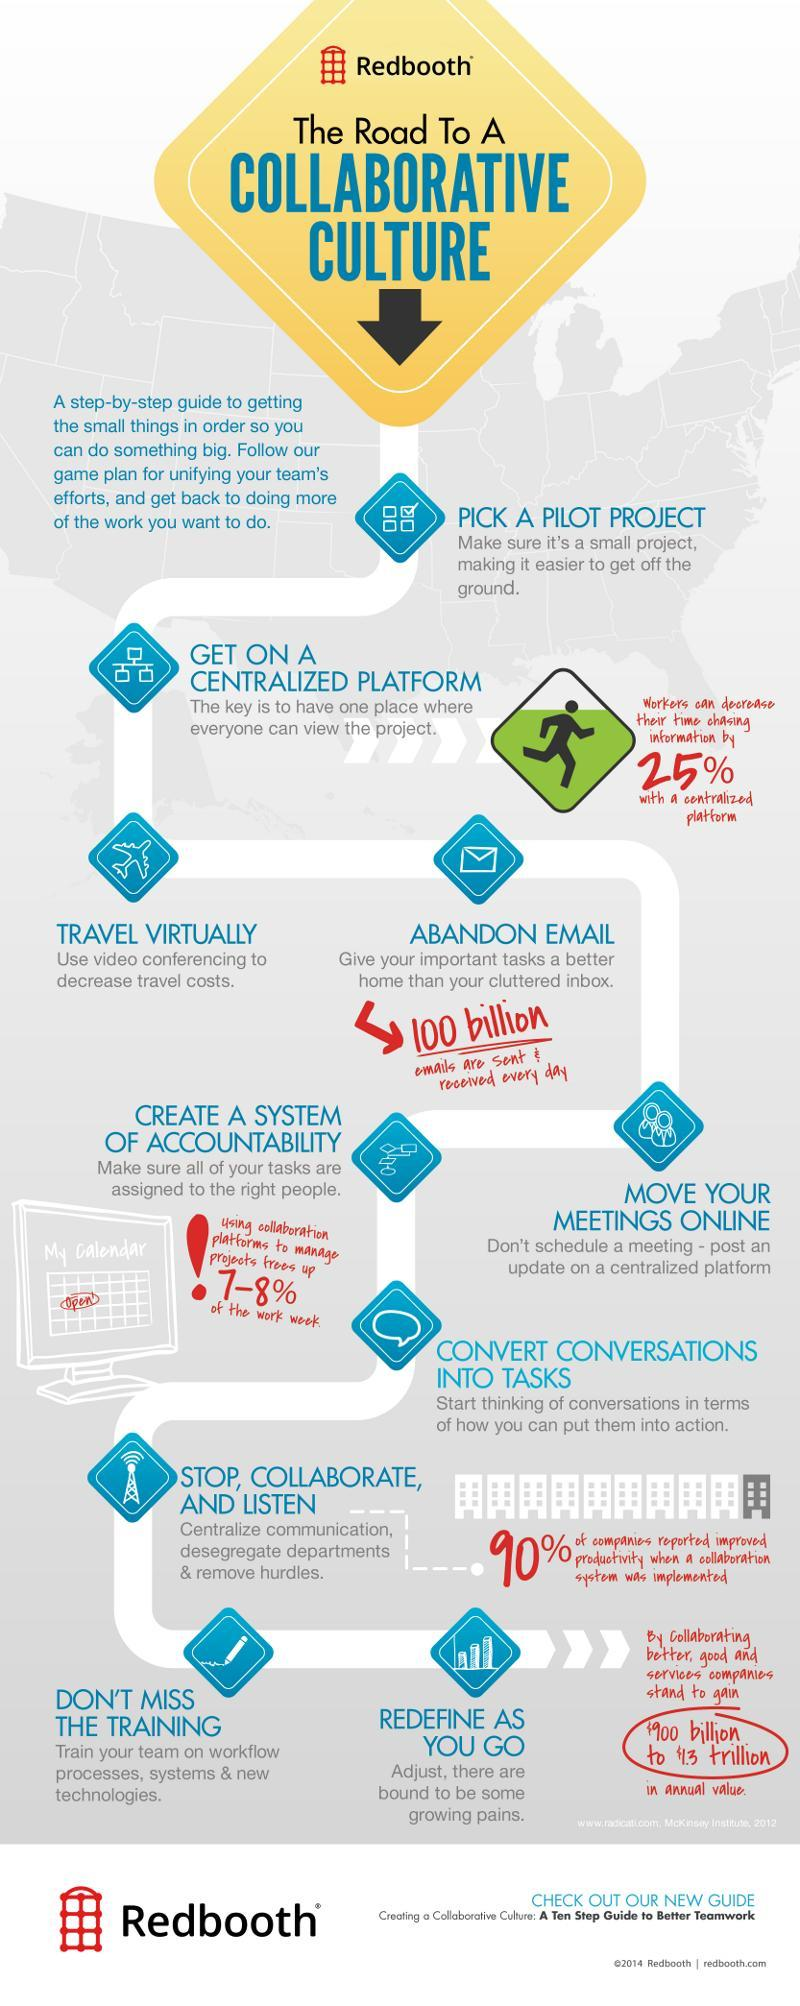what is the first step into collaborative culture?
Answer the question with a short phrase. pick a pilot project what is the next step after picking the pilot project? get on a centralized platform 